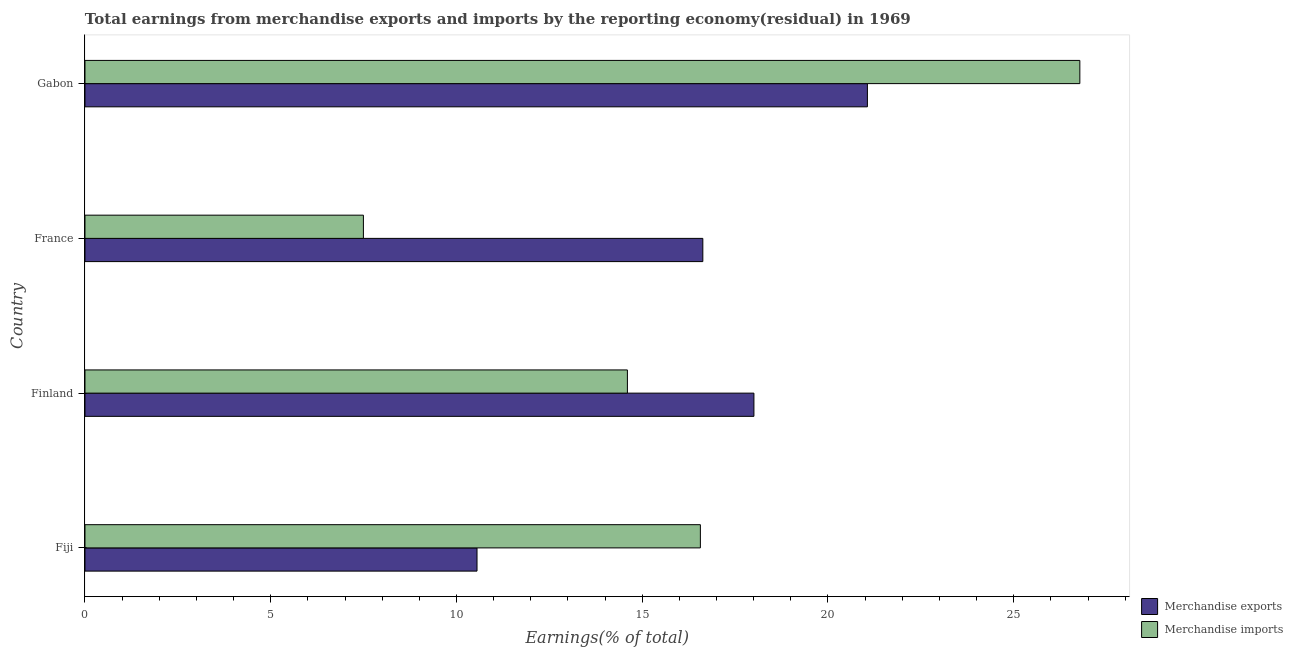Are the number of bars per tick equal to the number of legend labels?
Give a very brief answer. Yes. How many bars are there on the 1st tick from the top?
Your response must be concise. 2. What is the label of the 4th group of bars from the top?
Your answer should be compact. Fiji. In how many cases, is the number of bars for a given country not equal to the number of legend labels?
Provide a succinct answer. 0. What is the earnings from merchandise imports in France?
Provide a succinct answer. 7.49. Across all countries, what is the maximum earnings from merchandise imports?
Provide a succinct answer. 26.78. Across all countries, what is the minimum earnings from merchandise imports?
Your answer should be compact. 7.49. In which country was the earnings from merchandise exports maximum?
Your response must be concise. Gabon. What is the total earnings from merchandise exports in the graph?
Offer a terse response. 66.25. What is the difference between the earnings from merchandise exports in Fiji and that in Finland?
Give a very brief answer. -7.45. What is the difference between the earnings from merchandise imports in Finland and the earnings from merchandise exports in France?
Provide a short and direct response. -2.03. What is the average earnings from merchandise exports per country?
Offer a terse response. 16.56. What is the difference between the earnings from merchandise exports and earnings from merchandise imports in Finland?
Offer a terse response. 3.41. What is the ratio of the earnings from merchandise exports in Fiji to that in Gabon?
Provide a short and direct response. 0.5. What is the difference between the highest and the second highest earnings from merchandise exports?
Your answer should be very brief. 3.06. What is the difference between the highest and the lowest earnings from merchandise imports?
Give a very brief answer. 19.29. In how many countries, is the earnings from merchandise imports greater than the average earnings from merchandise imports taken over all countries?
Make the answer very short. 2. Are the values on the major ticks of X-axis written in scientific E-notation?
Give a very brief answer. No. Does the graph contain any zero values?
Offer a terse response. No. Does the graph contain grids?
Your response must be concise. No. Where does the legend appear in the graph?
Give a very brief answer. Bottom right. How many legend labels are there?
Make the answer very short. 2. How are the legend labels stacked?
Offer a terse response. Vertical. What is the title of the graph?
Your answer should be compact. Total earnings from merchandise exports and imports by the reporting economy(residual) in 1969. What is the label or title of the X-axis?
Give a very brief answer. Earnings(% of total). What is the Earnings(% of total) in Merchandise exports in Fiji?
Provide a succinct answer. 10.55. What is the Earnings(% of total) of Merchandise imports in Fiji?
Offer a terse response. 16.57. What is the Earnings(% of total) in Merchandise exports in Finland?
Ensure brevity in your answer.  18.01. What is the Earnings(% of total) of Merchandise imports in Finland?
Your answer should be compact. 14.6. What is the Earnings(% of total) in Merchandise exports in France?
Keep it short and to the point. 16.63. What is the Earnings(% of total) of Merchandise imports in France?
Provide a succinct answer. 7.49. What is the Earnings(% of total) in Merchandise exports in Gabon?
Make the answer very short. 21.06. What is the Earnings(% of total) of Merchandise imports in Gabon?
Offer a terse response. 26.78. Across all countries, what is the maximum Earnings(% of total) of Merchandise exports?
Offer a very short reply. 21.06. Across all countries, what is the maximum Earnings(% of total) of Merchandise imports?
Make the answer very short. 26.78. Across all countries, what is the minimum Earnings(% of total) in Merchandise exports?
Your answer should be compact. 10.55. Across all countries, what is the minimum Earnings(% of total) of Merchandise imports?
Offer a very short reply. 7.49. What is the total Earnings(% of total) in Merchandise exports in the graph?
Offer a terse response. 66.25. What is the total Earnings(% of total) of Merchandise imports in the graph?
Provide a succinct answer. 65.44. What is the difference between the Earnings(% of total) of Merchandise exports in Fiji and that in Finland?
Ensure brevity in your answer.  -7.45. What is the difference between the Earnings(% of total) of Merchandise imports in Fiji and that in Finland?
Your answer should be very brief. 1.96. What is the difference between the Earnings(% of total) in Merchandise exports in Fiji and that in France?
Offer a terse response. -6.08. What is the difference between the Earnings(% of total) in Merchandise imports in Fiji and that in France?
Offer a very short reply. 9.07. What is the difference between the Earnings(% of total) of Merchandise exports in Fiji and that in Gabon?
Your answer should be compact. -10.51. What is the difference between the Earnings(% of total) in Merchandise imports in Fiji and that in Gabon?
Your response must be concise. -10.21. What is the difference between the Earnings(% of total) in Merchandise exports in Finland and that in France?
Keep it short and to the point. 1.38. What is the difference between the Earnings(% of total) in Merchandise imports in Finland and that in France?
Your response must be concise. 7.11. What is the difference between the Earnings(% of total) of Merchandise exports in Finland and that in Gabon?
Offer a very short reply. -3.05. What is the difference between the Earnings(% of total) of Merchandise imports in Finland and that in Gabon?
Keep it short and to the point. -12.18. What is the difference between the Earnings(% of total) in Merchandise exports in France and that in Gabon?
Make the answer very short. -4.43. What is the difference between the Earnings(% of total) of Merchandise imports in France and that in Gabon?
Make the answer very short. -19.29. What is the difference between the Earnings(% of total) of Merchandise exports in Fiji and the Earnings(% of total) of Merchandise imports in Finland?
Keep it short and to the point. -4.05. What is the difference between the Earnings(% of total) of Merchandise exports in Fiji and the Earnings(% of total) of Merchandise imports in France?
Keep it short and to the point. 3.06. What is the difference between the Earnings(% of total) in Merchandise exports in Fiji and the Earnings(% of total) in Merchandise imports in Gabon?
Provide a short and direct response. -16.23. What is the difference between the Earnings(% of total) in Merchandise exports in Finland and the Earnings(% of total) in Merchandise imports in France?
Offer a terse response. 10.51. What is the difference between the Earnings(% of total) in Merchandise exports in Finland and the Earnings(% of total) in Merchandise imports in Gabon?
Provide a short and direct response. -8.77. What is the difference between the Earnings(% of total) in Merchandise exports in France and the Earnings(% of total) in Merchandise imports in Gabon?
Your answer should be compact. -10.15. What is the average Earnings(% of total) in Merchandise exports per country?
Provide a succinct answer. 16.56. What is the average Earnings(% of total) in Merchandise imports per country?
Your answer should be compact. 16.36. What is the difference between the Earnings(% of total) in Merchandise exports and Earnings(% of total) in Merchandise imports in Fiji?
Offer a very short reply. -6.01. What is the difference between the Earnings(% of total) in Merchandise exports and Earnings(% of total) in Merchandise imports in Finland?
Offer a terse response. 3.41. What is the difference between the Earnings(% of total) of Merchandise exports and Earnings(% of total) of Merchandise imports in France?
Make the answer very short. 9.14. What is the difference between the Earnings(% of total) in Merchandise exports and Earnings(% of total) in Merchandise imports in Gabon?
Give a very brief answer. -5.72. What is the ratio of the Earnings(% of total) in Merchandise exports in Fiji to that in Finland?
Provide a succinct answer. 0.59. What is the ratio of the Earnings(% of total) of Merchandise imports in Fiji to that in Finland?
Provide a succinct answer. 1.13. What is the ratio of the Earnings(% of total) in Merchandise exports in Fiji to that in France?
Your answer should be very brief. 0.63. What is the ratio of the Earnings(% of total) in Merchandise imports in Fiji to that in France?
Ensure brevity in your answer.  2.21. What is the ratio of the Earnings(% of total) of Merchandise exports in Fiji to that in Gabon?
Your answer should be compact. 0.5. What is the ratio of the Earnings(% of total) of Merchandise imports in Fiji to that in Gabon?
Give a very brief answer. 0.62. What is the ratio of the Earnings(% of total) in Merchandise exports in Finland to that in France?
Offer a terse response. 1.08. What is the ratio of the Earnings(% of total) of Merchandise imports in Finland to that in France?
Your answer should be very brief. 1.95. What is the ratio of the Earnings(% of total) of Merchandise exports in Finland to that in Gabon?
Your response must be concise. 0.85. What is the ratio of the Earnings(% of total) of Merchandise imports in Finland to that in Gabon?
Provide a succinct answer. 0.55. What is the ratio of the Earnings(% of total) in Merchandise exports in France to that in Gabon?
Offer a very short reply. 0.79. What is the ratio of the Earnings(% of total) in Merchandise imports in France to that in Gabon?
Offer a very short reply. 0.28. What is the difference between the highest and the second highest Earnings(% of total) of Merchandise exports?
Ensure brevity in your answer.  3.05. What is the difference between the highest and the second highest Earnings(% of total) of Merchandise imports?
Keep it short and to the point. 10.21. What is the difference between the highest and the lowest Earnings(% of total) in Merchandise exports?
Provide a short and direct response. 10.51. What is the difference between the highest and the lowest Earnings(% of total) of Merchandise imports?
Give a very brief answer. 19.29. 